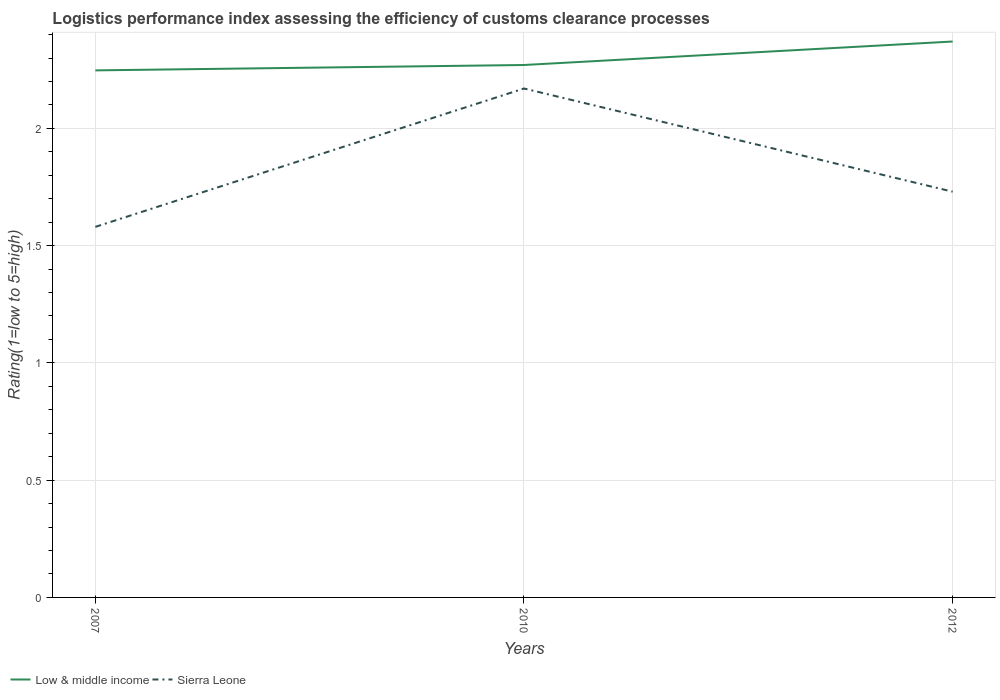Does the line corresponding to Low & middle income intersect with the line corresponding to Sierra Leone?
Provide a short and direct response. No. Across all years, what is the maximum Logistic performance index in Low & middle income?
Your response must be concise. 2.25. In which year was the Logistic performance index in Sierra Leone maximum?
Provide a succinct answer. 2007. What is the total Logistic performance index in Low & middle income in the graph?
Keep it short and to the point. -0.02. What is the difference between the highest and the second highest Logistic performance index in Low & middle income?
Offer a terse response. 0.12. Are the values on the major ticks of Y-axis written in scientific E-notation?
Provide a succinct answer. No. Does the graph contain any zero values?
Provide a succinct answer. No. Does the graph contain grids?
Make the answer very short. Yes. How are the legend labels stacked?
Your answer should be very brief. Horizontal. What is the title of the graph?
Give a very brief answer. Logistics performance index assessing the efficiency of customs clearance processes. Does "Honduras" appear as one of the legend labels in the graph?
Your answer should be compact. No. What is the label or title of the X-axis?
Make the answer very short. Years. What is the label or title of the Y-axis?
Your answer should be very brief. Rating(1=low to 5=high). What is the Rating(1=low to 5=high) in Low & middle income in 2007?
Your answer should be compact. 2.25. What is the Rating(1=low to 5=high) of Sierra Leone in 2007?
Your answer should be compact. 1.58. What is the Rating(1=low to 5=high) of Low & middle income in 2010?
Your answer should be compact. 2.27. What is the Rating(1=low to 5=high) in Sierra Leone in 2010?
Make the answer very short. 2.17. What is the Rating(1=low to 5=high) in Low & middle income in 2012?
Offer a very short reply. 2.37. What is the Rating(1=low to 5=high) in Sierra Leone in 2012?
Give a very brief answer. 1.73. Across all years, what is the maximum Rating(1=low to 5=high) of Low & middle income?
Offer a very short reply. 2.37. Across all years, what is the maximum Rating(1=low to 5=high) in Sierra Leone?
Your answer should be very brief. 2.17. Across all years, what is the minimum Rating(1=low to 5=high) in Low & middle income?
Offer a terse response. 2.25. Across all years, what is the minimum Rating(1=low to 5=high) in Sierra Leone?
Offer a very short reply. 1.58. What is the total Rating(1=low to 5=high) of Low & middle income in the graph?
Give a very brief answer. 6.89. What is the total Rating(1=low to 5=high) in Sierra Leone in the graph?
Give a very brief answer. 5.48. What is the difference between the Rating(1=low to 5=high) of Low & middle income in 2007 and that in 2010?
Offer a terse response. -0.02. What is the difference between the Rating(1=low to 5=high) of Sierra Leone in 2007 and that in 2010?
Your answer should be very brief. -0.59. What is the difference between the Rating(1=low to 5=high) of Low & middle income in 2007 and that in 2012?
Provide a succinct answer. -0.12. What is the difference between the Rating(1=low to 5=high) of Low & middle income in 2010 and that in 2012?
Your answer should be compact. -0.1. What is the difference between the Rating(1=low to 5=high) of Sierra Leone in 2010 and that in 2012?
Offer a terse response. 0.44. What is the difference between the Rating(1=low to 5=high) of Low & middle income in 2007 and the Rating(1=low to 5=high) of Sierra Leone in 2010?
Your answer should be compact. 0.08. What is the difference between the Rating(1=low to 5=high) of Low & middle income in 2007 and the Rating(1=low to 5=high) of Sierra Leone in 2012?
Give a very brief answer. 0.52. What is the difference between the Rating(1=low to 5=high) of Low & middle income in 2010 and the Rating(1=low to 5=high) of Sierra Leone in 2012?
Provide a succinct answer. 0.54. What is the average Rating(1=low to 5=high) of Low & middle income per year?
Keep it short and to the point. 2.3. What is the average Rating(1=low to 5=high) in Sierra Leone per year?
Provide a succinct answer. 1.83. In the year 2007, what is the difference between the Rating(1=low to 5=high) of Low & middle income and Rating(1=low to 5=high) of Sierra Leone?
Offer a terse response. 0.67. In the year 2010, what is the difference between the Rating(1=low to 5=high) in Low & middle income and Rating(1=low to 5=high) in Sierra Leone?
Your answer should be very brief. 0.1. In the year 2012, what is the difference between the Rating(1=low to 5=high) in Low & middle income and Rating(1=low to 5=high) in Sierra Leone?
Keep it short and to the point. 0.64. What is the ratio of the Rating(1=low to 5=high) of Low & middle income in 2007 to that in 2010?
Your answer should be compact. 0.99. What is the ratio of the Rating(1=low to 5=high) in Sierra Leone in 2007 to that in 2010?
Make the answer very short. 0.73. What is the ratio of the Rating(1=low to 5=high) in Low & middle income in 2007 to that in 2012?
Your answer should be compact. 0.95. What is the ratio of the Rating(1=low to 5=high) of Sierra Leone in 2007 to that in 2012?
Provide a short and direct response. 0.91. What is the ratio of the Rating(1=low to 5=high) in Low & middle income in 2010 to that in 2012?
Ensure brevity in your answer.  0.96. What is the ratio of the Rating(1=low to 5=high) of Sierra Leone in 2010 to that in 2012?
Ensure brevity in your answer.  1.25. What is the difference between the highest and the second highest Rating(1=low to 5=high) in Low & middle income?
Your response must be concise. 0.1. What is the difference between the highest and the second highest Rating(1=low to 5=high) in Sierra Leone?
Your answer should be compact. 0.44. What is the difference between the highest and the lowest Rating(1=low to 5=high) in Low & middle income?
Offer a terse response. 0.12. What is the difference between the highest and the lowest Rating(1=low to 5=high) in Sierra Leone?
Offer a terse response. 0.59. 